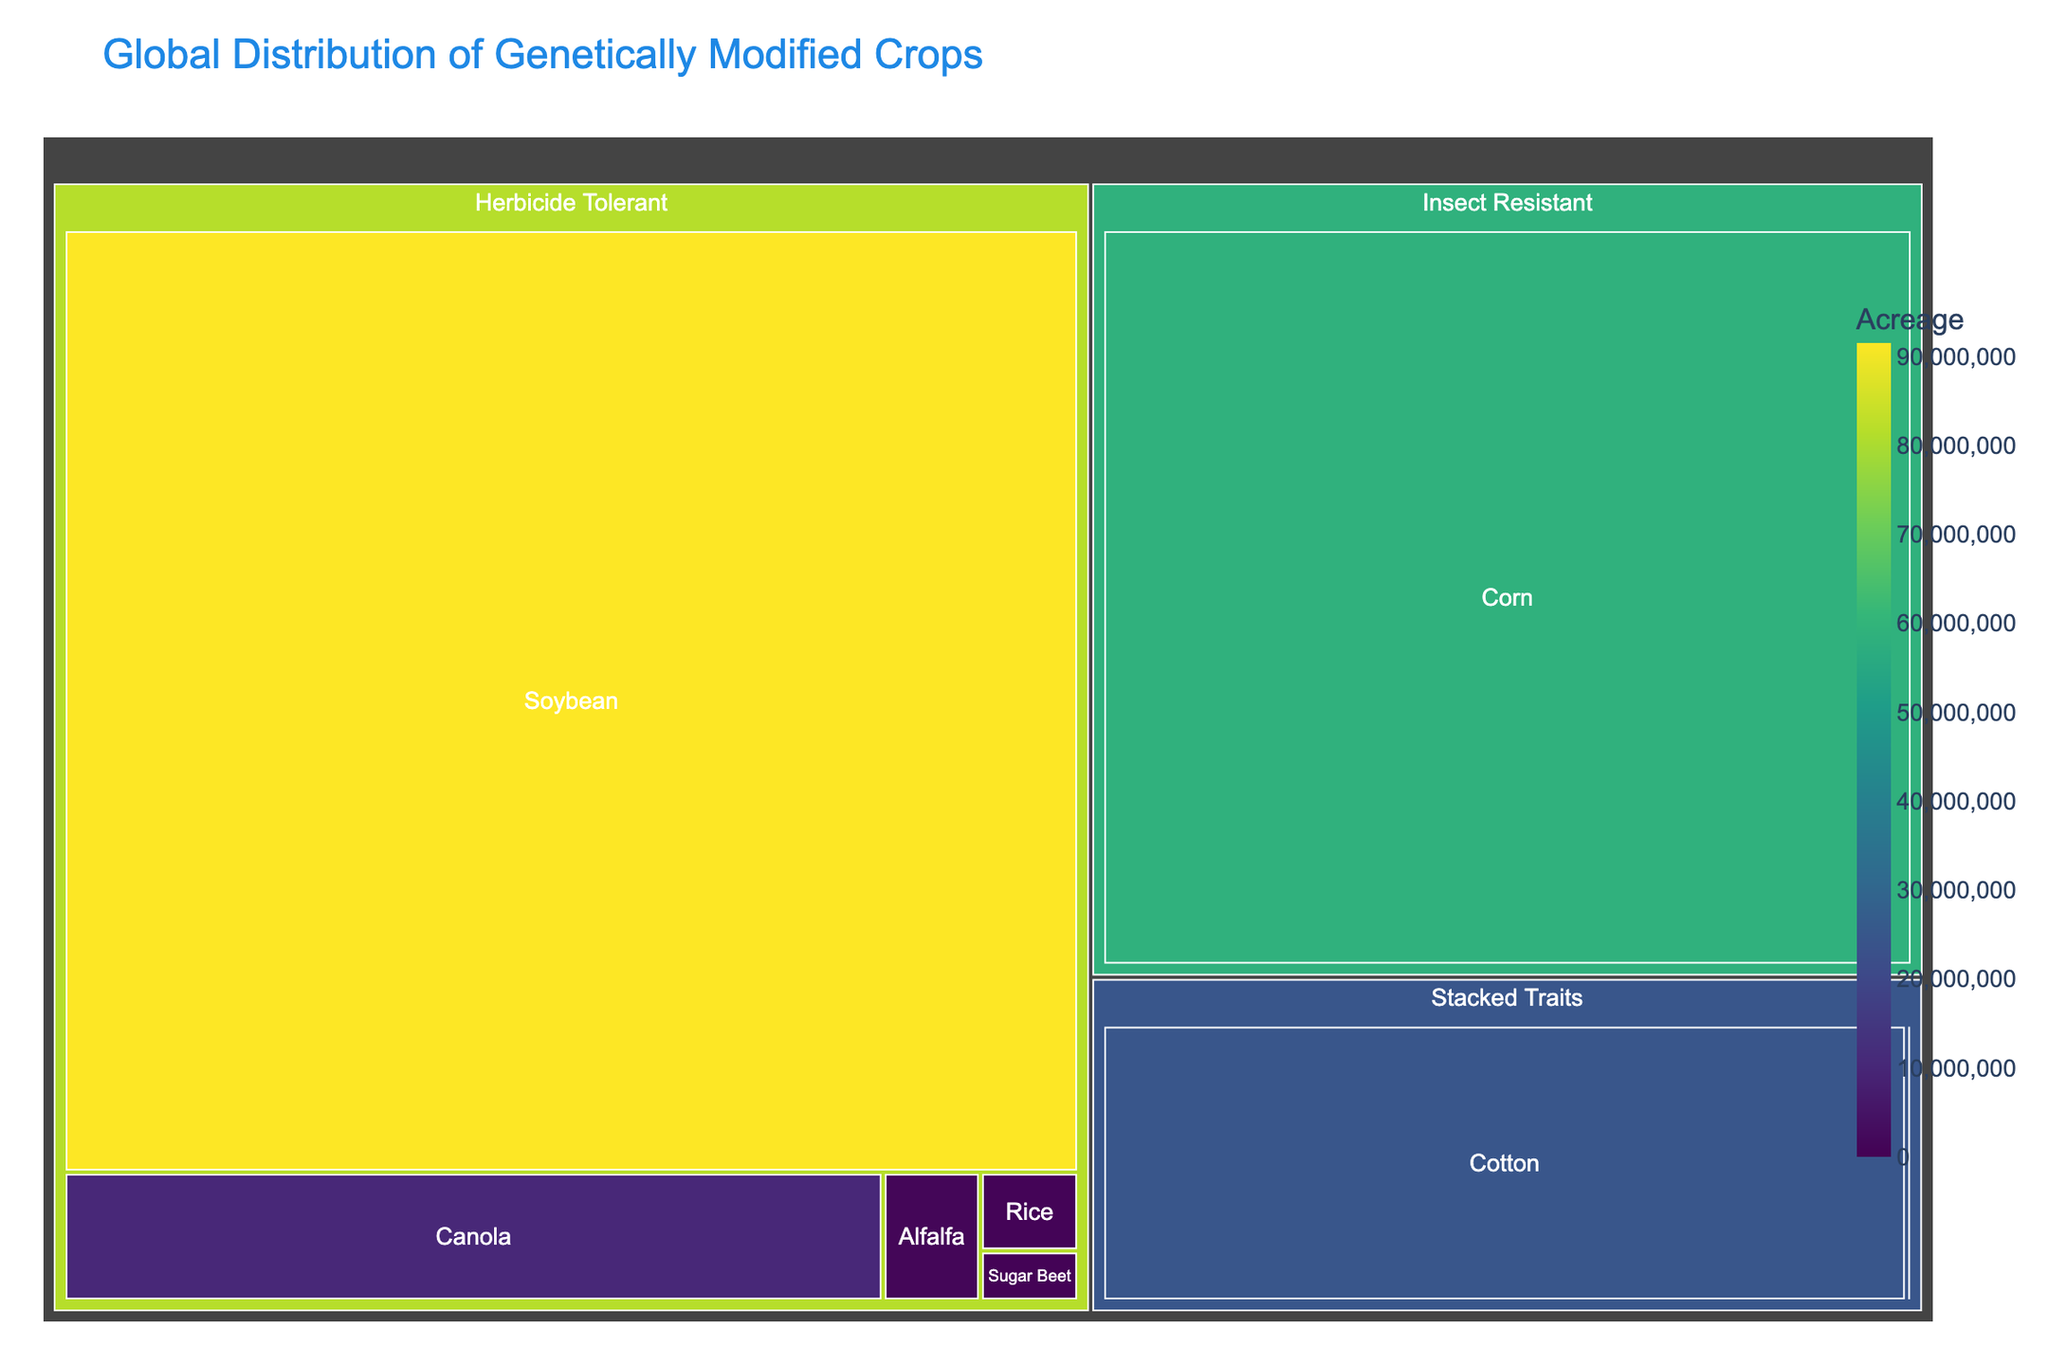What is the title of the treemap? The title is usually prominently displayed at the top of the figure.
Answer: Global Distribution of Genetically Modified Crops Which genetically modified crop has the largest acreage? By looking at the size of the rectangles, the largest area represents the genetically modified crop with the largest acreage.
Answer: Soybean (Herbicide Tolerant) What is the total acreage of genetically modified crops under the "Herbicide Tolerant" type? Sum the acreage values for all crops listed under "Herbicide Tolerant." The crops are Soybean, Canola, Alfalfa, Sugar Beet, and Rice. 91500000 + 10100000 + 1200000 + 472000 + 740000
Answer: 104,320,000 How many types of genetically modified crops are shown in the treemap? Count the unique distinct labels under the "Type" section in the treemap. The types are Herbicide Tolerant, Insect Resistant, Stacked Traits, Virus Resistant, and Non-Browning.
Answer: 5 Which type has the smallest total acreage? Compare the total acreage for each type. First calculate the total for each type, then identify the one with the smallest sum.
Answer: Non-Browning Which crop and type combination has the smallest acreage? Find the smallest rectangle in the treemap which represents the smallest acreage value.
Answer: Squash (Virus Resistant) Is the average acreage for "Insect Resistant" crops higher than that of "Virus Resistant" crops? Calculate the average acreage for each type by summing their acreages and dividing by the number of crops in each type. For Insect Resistant: (58700000 + 1200) / 2 = 29350600. For Virus Resistant: (12000 + 2500) / 2 = 7250. Compare the two results.
Answer: Yes Which crop within the "Stacked Traits" category has a higher acreage, Cotton or Potato? Compare the sizes of the rectangles for Cotton and Potato within the "Stacked Traits" category.
Answer: Cotton What's the acreage difference between Corn and Cotton? Subtract the acreage value of Cotton from that of Corn. 58700000 - 24600000
Answer: 34,100,000 Are there more crops categorized as "Herbicide Tolerant" or "Virus Resistant"? If more, by how many? Count the number of crops listed under each category. Herbicide Tolerant has Soybean, Canola, Alfalfa, Sugar Beet, and Rice (5 crops). Virus Resistant has Papaya and Squash (2 crops). 5 - 2
Answer: Yes, by 3 